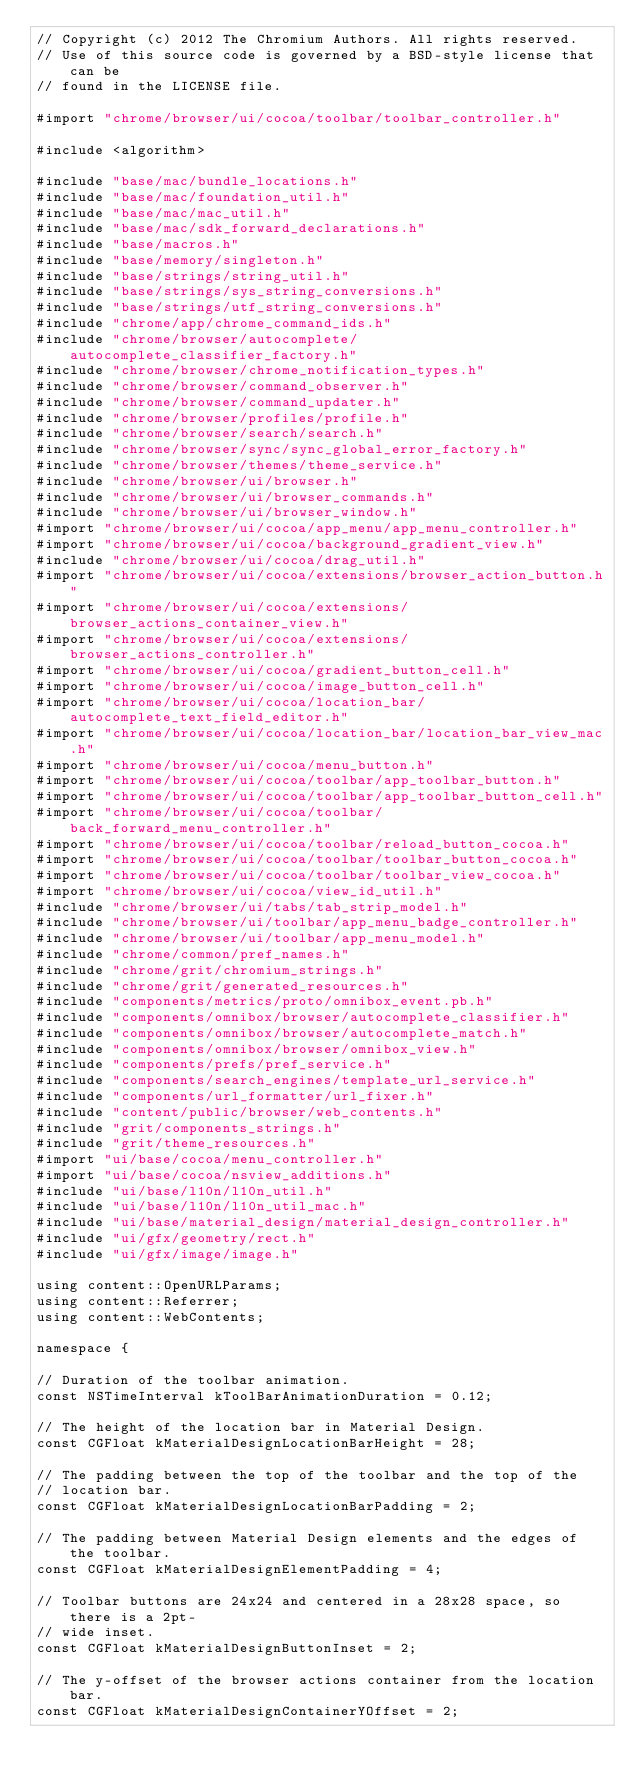Convert code to text. <code><loc_0><loc_0><loc_500><loc_500><_ObjectiveC_>// Copyright (c) 2012 The Chromium Authors. All rights reserved.
// Use of this source code is governed by a BSD-style license that can be
// found in the LICENSE file.

#import "chrome/browser/ui/cocoa/toolbar/toolbar_controller.h"

#include <algorithm>

#include "base/mac/bundle_locations.h"
#include "base/mac/foundation_util.h"
#include "base/mac/mac_util.h"
#include "base/mac/sdk_forward_declarations.h"
#include "base/macros.h"
#include "base/memory/singleton.h"
#include "base/strings/string_util.h"
#include "base/strings/sys_string_conversions.h"
#include "base/strings/utf_string_conversions.h"
#include "chrome/app/chrome_command_ids.h"
#include "chrome/browser/autocomplete/autocomplete_classifier_factory.h"
#include "chrome/browser/chrome_notification_types.h"
#include "chrome/browser/command_observer.h"
#include "chrome/browser/command_updater.h"
#include "chrome/browser/profiles/profile.h"
#include "chrome/browser/search/search.h"
#include "chrome/browser/sync/sync_global_error_factory.h"
#include "chrome/browser/themes/theme_service.h"
#include "chrome/browser/ui/browser.h"
#include "chrome/browser/ui/browser_commands.h"
#include "chrome/browser/ui/browser_window.h"
#import "chrome/browser/ui/cocoa/app_menu/app_menu_controller.h"
#import "chrome/browser/ui/cocoa/background_gradient_view.h"
#include "chrome/browser/ui/cocoa/drag_util.h"
#import "chrome/browser/ui/cocoa/extensions/browser_action_button.h"
#import "chrome/browser/ui/cocoa/extensions/browser_actions_container_view.h"
#import "chrome/browser/ui/cocoa/extensions/browser_actions_controller.h"
#import "chrome/browser/ui/cocoa/gradient_button_cell.h"
#import "chrome/browser/ui/cocoa/image_button_cell.h"
#import "chrome/browser/ui/cocoa/location_bar/autocomplete_text_field_editor.h"
#import "chrome/browser/ui/cocoa/location_bar/location_bar_view_mac.h"
#import "chrome/browser/ui/cocoa/menu_button.h"
#import "chrome/browser/ui/cocoa/toolbar/app_toolbar_button.h"
#import "chrome/browser/ui/cocoa/toolbar/app_toolbar_button_cell.h"
#import "chrome/browser/ui/cocoa/toolbar/back_forward_menu_controller.h"
#import "chrome/browser/ui/cocoa/toolbar/reload_button_cocoa.h"
#import "chrome/browser/ui/cocoa/toolbar/toolbar_button_cocoa.h"
#import "chrome/browser/ui/cocoa/toolbar/toolbar_view_cocoa.h"
#import "chrome/browser/ui/cocoa/view_id_util.h"
#include "chrome/browser/ui/tabs/tab_strip_model.h"
#include "chrome/browser/ui/toolbar/app_menu_badge_controller.h"
#include "chrome/browser/ui/toolbar/app_menu_model.h"
#include "chrome/common/pref_names.h"
#include "chrome/grit/chromium_strings.h"
#include "chrome/grit/generated_resources.h"
#include "components/metrics/proto/omnibox_event.pb.h"
#include "components/omnibox/browser/autocomplete_classifier.h"
#include "components/omnibox/browser/autocomplete_match.h"
#include "components/omnibox/browser/omnibox_view.h"
#include "components/prefs/pref_service.h"
#include "components/search_engines/template_url_service.h"
#include "components/url_formatter/url_fixer.h"
#include "content/public/browser/web_contents.h"
#include "grit/components_strings.h"
#include "grit/theme_resources.h"
#import "ui/base/cocoa/menu_controller.h"
#import "ui/base/cocoa/nsview_additions.h"
#include "ui/base/l10n/l10n_util.h"
#include "ui/base/l10n/l10n_util_mac.h"
#include "ui/base/material_design/material_design_controller.h"
#include "ui/gfx/geometry/rect.h"
#include "ui/gfx/image/image.h"

using content::OpenURLParams;
using content::Referrer;
using content::WebContents;

namespace {

// Duration of the toolbar animation.
const NSTimeInterval kToolBarAnimationDuration = 0.12;

// The height of the location bar in Material Design.
const CGFloat kMaterialDesignLocationBarHeight = 28;

// The padding between the top of the toolbar and the top of the
// location bar.
const CGFloat kMaterialDesignLocationBarPadding = 2;

// The padding between Material Design elements and the edges of the toolbar.
const CGFloat kMaterialDesignElementPadding = 4;

// Toolbar buttons are 24x24 and centered in a 28x28 space, so there is a 2pt-
// wide inset.
const CGFloat kMaterialDesignButtonInset = 2;

// The y-offset of the browser actions container from the location bar.
const CGFloat kMaterialDesignContainerYOffset = 2;
</code> 